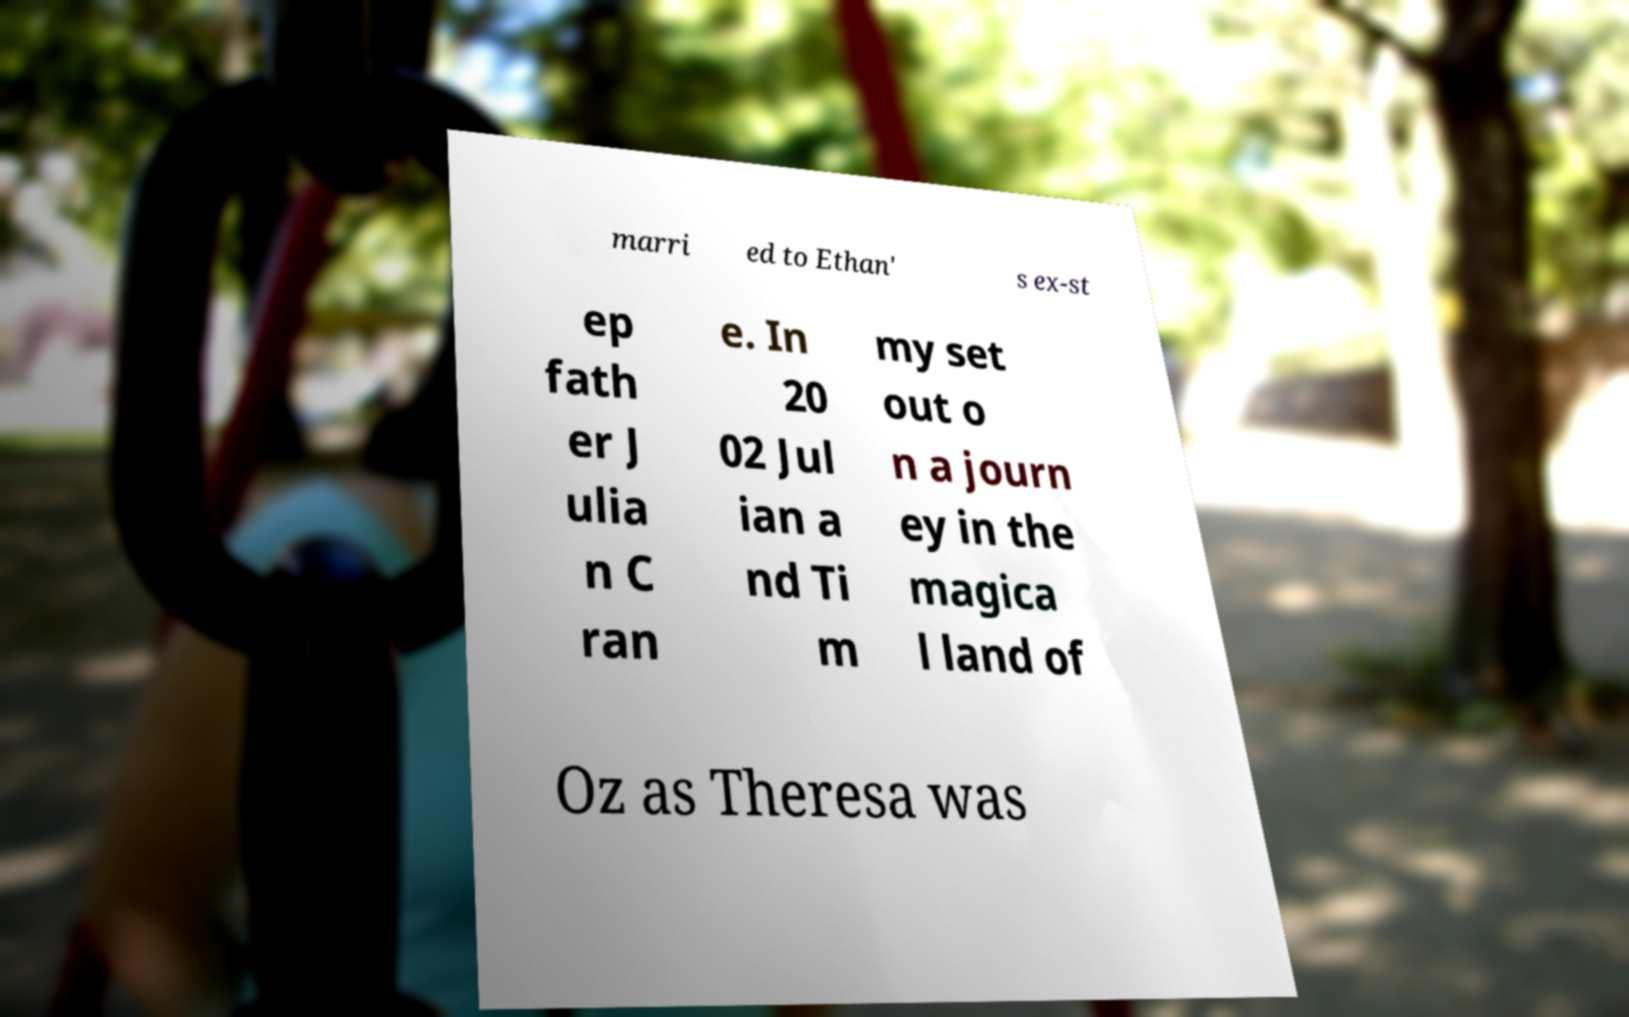There's text embedded in this image that I need extracted. Can you transcribe it verbatim? marri ed to Ethan' s ex-st ep fath er J ulia n C ran e. In 20 02 Jul ian a nd Ti m my set out o n a journ ey in the magica l land of Oz as Theresa was 